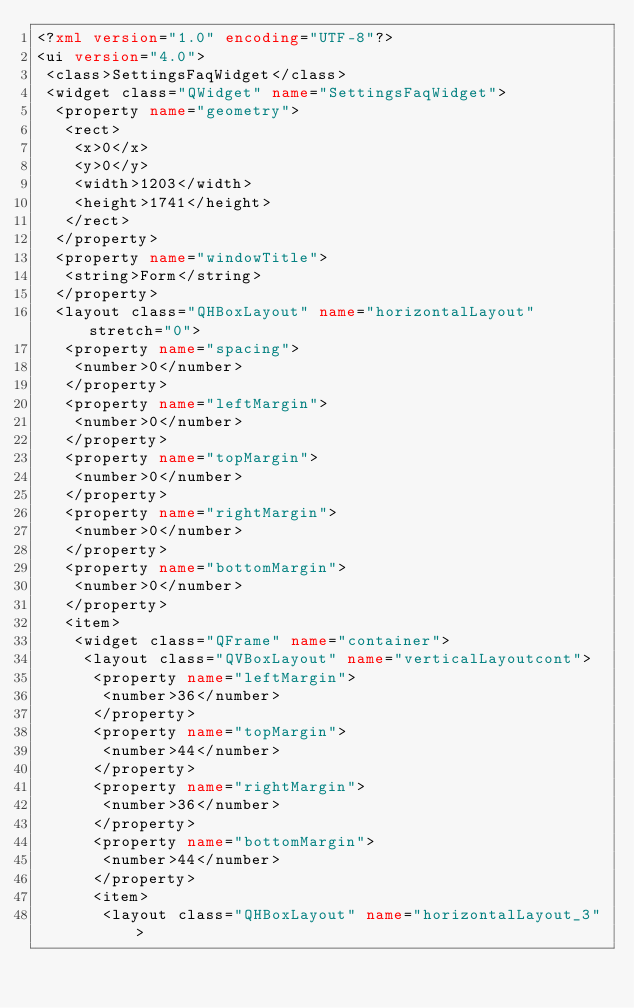<code> <loc_0><loc_0><loc_500><loc_500><_XML_><?xml version="1.0" encoding="UTF-8"?>
<ui version="4.0">
 <class>SettingsFaqWidget</class>
 <widget class="QWidget" name="SettingsFaqWidget">
  <property name="geometry">
   <rect>
    <x>0</x>
    <y>0</y>
    <width>1203</width>
    <height>1741</height>
   </rect>
  </property>
  <property name="windowTitle">
   <string>Form</string>
  </property>
  <layout class="QHBoxLayout" name="horizontalLayout" stretch="0">
   <property name="spacing">
    <number>0</number>
   </property>
   <property name="leftMargin">
    <number>0</number>
   </property>
   <property name="topMargin">
    <number>0</number>
   </property>
   <property name="rightMargin">
    <number>0</number>
   </property>
   <property name="bottomMargin">
    <number>0</number>
   </property>
   <item>
    <widget class="QFrame" name="container">
     <layout class="QVBoxLayout" name="verticalLayoutcont">
      <property name="leftMargin">
       <number>36</number>
      </property>
      <property name="topMargin">
       <number>44</number>
      </property>
      <property name="rightMargin">
       <number>36</number>
      </property>
      <property name="bottomMargin">
       <number>44</number>
      </property>
      <item>
       <layout class="QHBoxLayout" name="horizontalLayout_3"></code> 